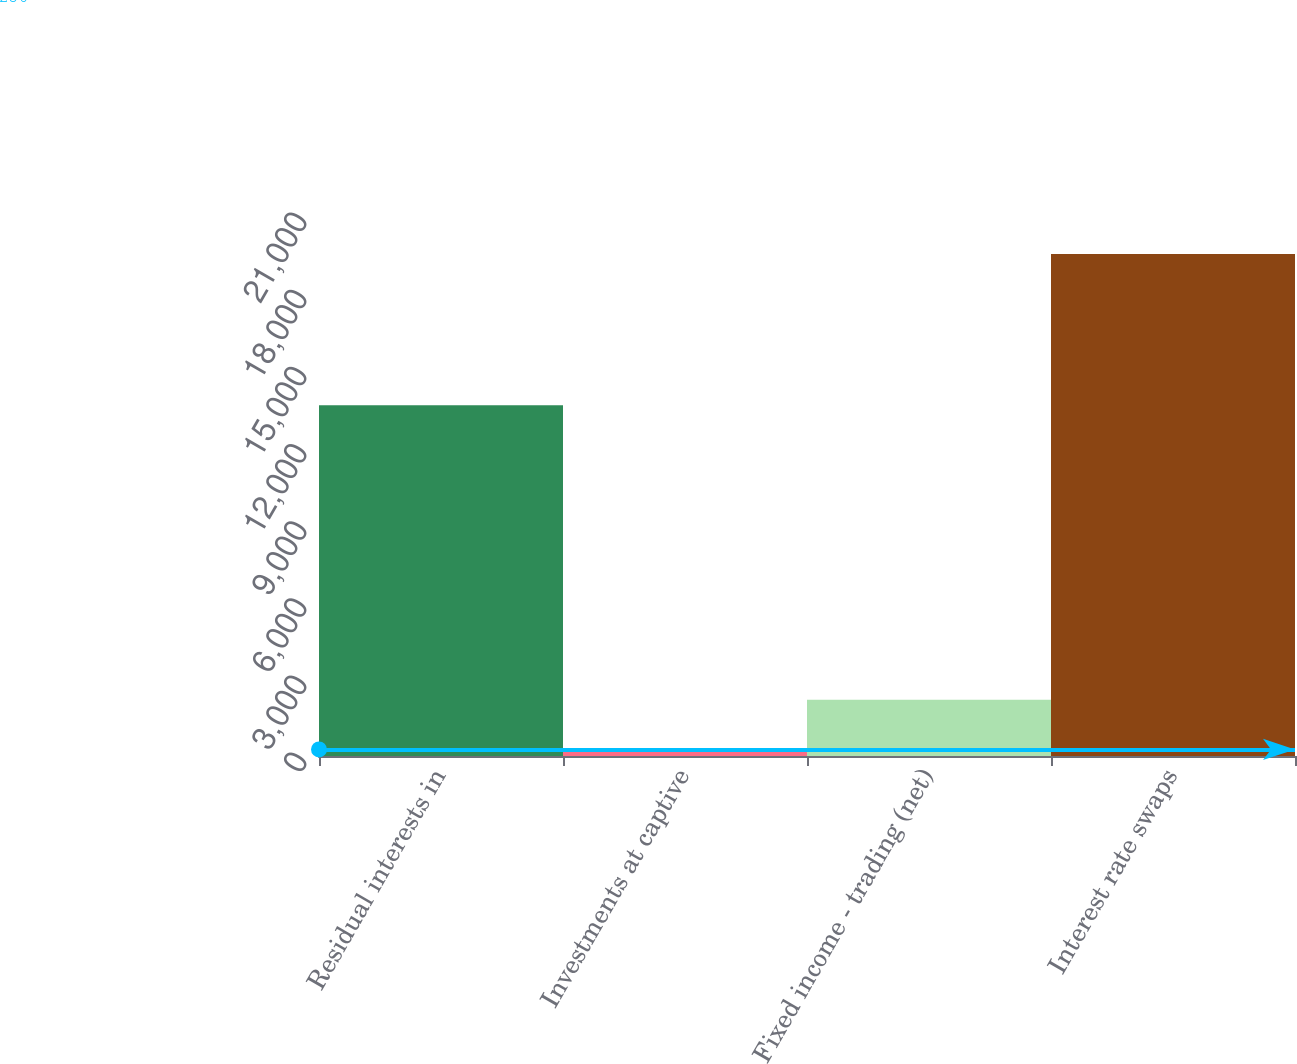<chart> <loc_0><loc_0><loc_500><loc_500><bar_chart><fcel>Residual interests in<fcel>Investments at captive<fcel>Fixed income - trading (net)<fcel>Interest rate swaps<nl><fcel>13637<fcel>256<fcel>2182.8<fcel>19524<nl></chart> 